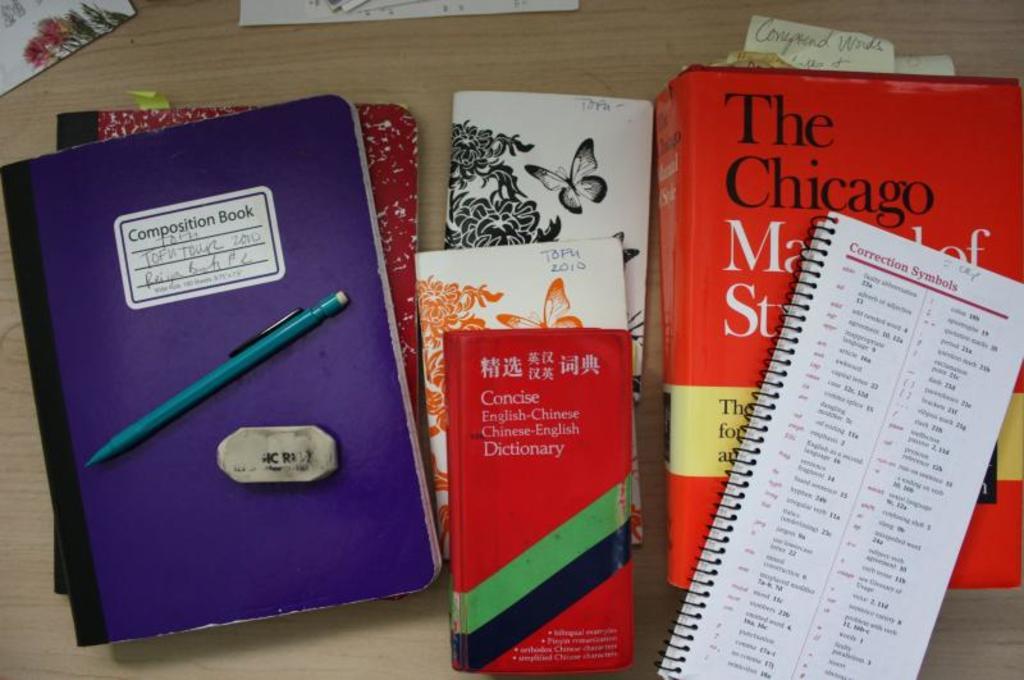What is the title of the book?
Give a very brief answer. The chicago. What kind of dictionary is that?
Your answer should be compact. English-chinese. 